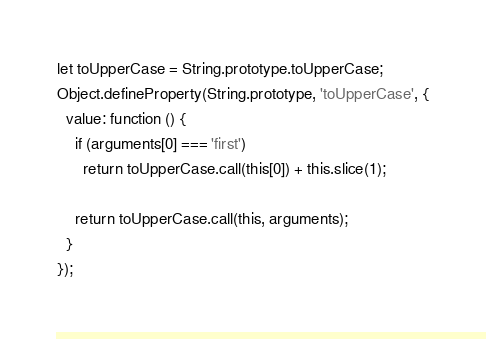<code> <loc_0><loc_0><loc_500><loc_500><_JavaScript_>let toUpperCase = String.prototype.toUpperCase;
Object.defineProperty(String.prototype, 'toUpperCase', {
  value: function () {
    if (arguments[0] === 'first')
      return toUpperCase.call(this[0]) + this.slice(1);

    return toUpperCase.call(this, arguments);
  }
});
</code> 